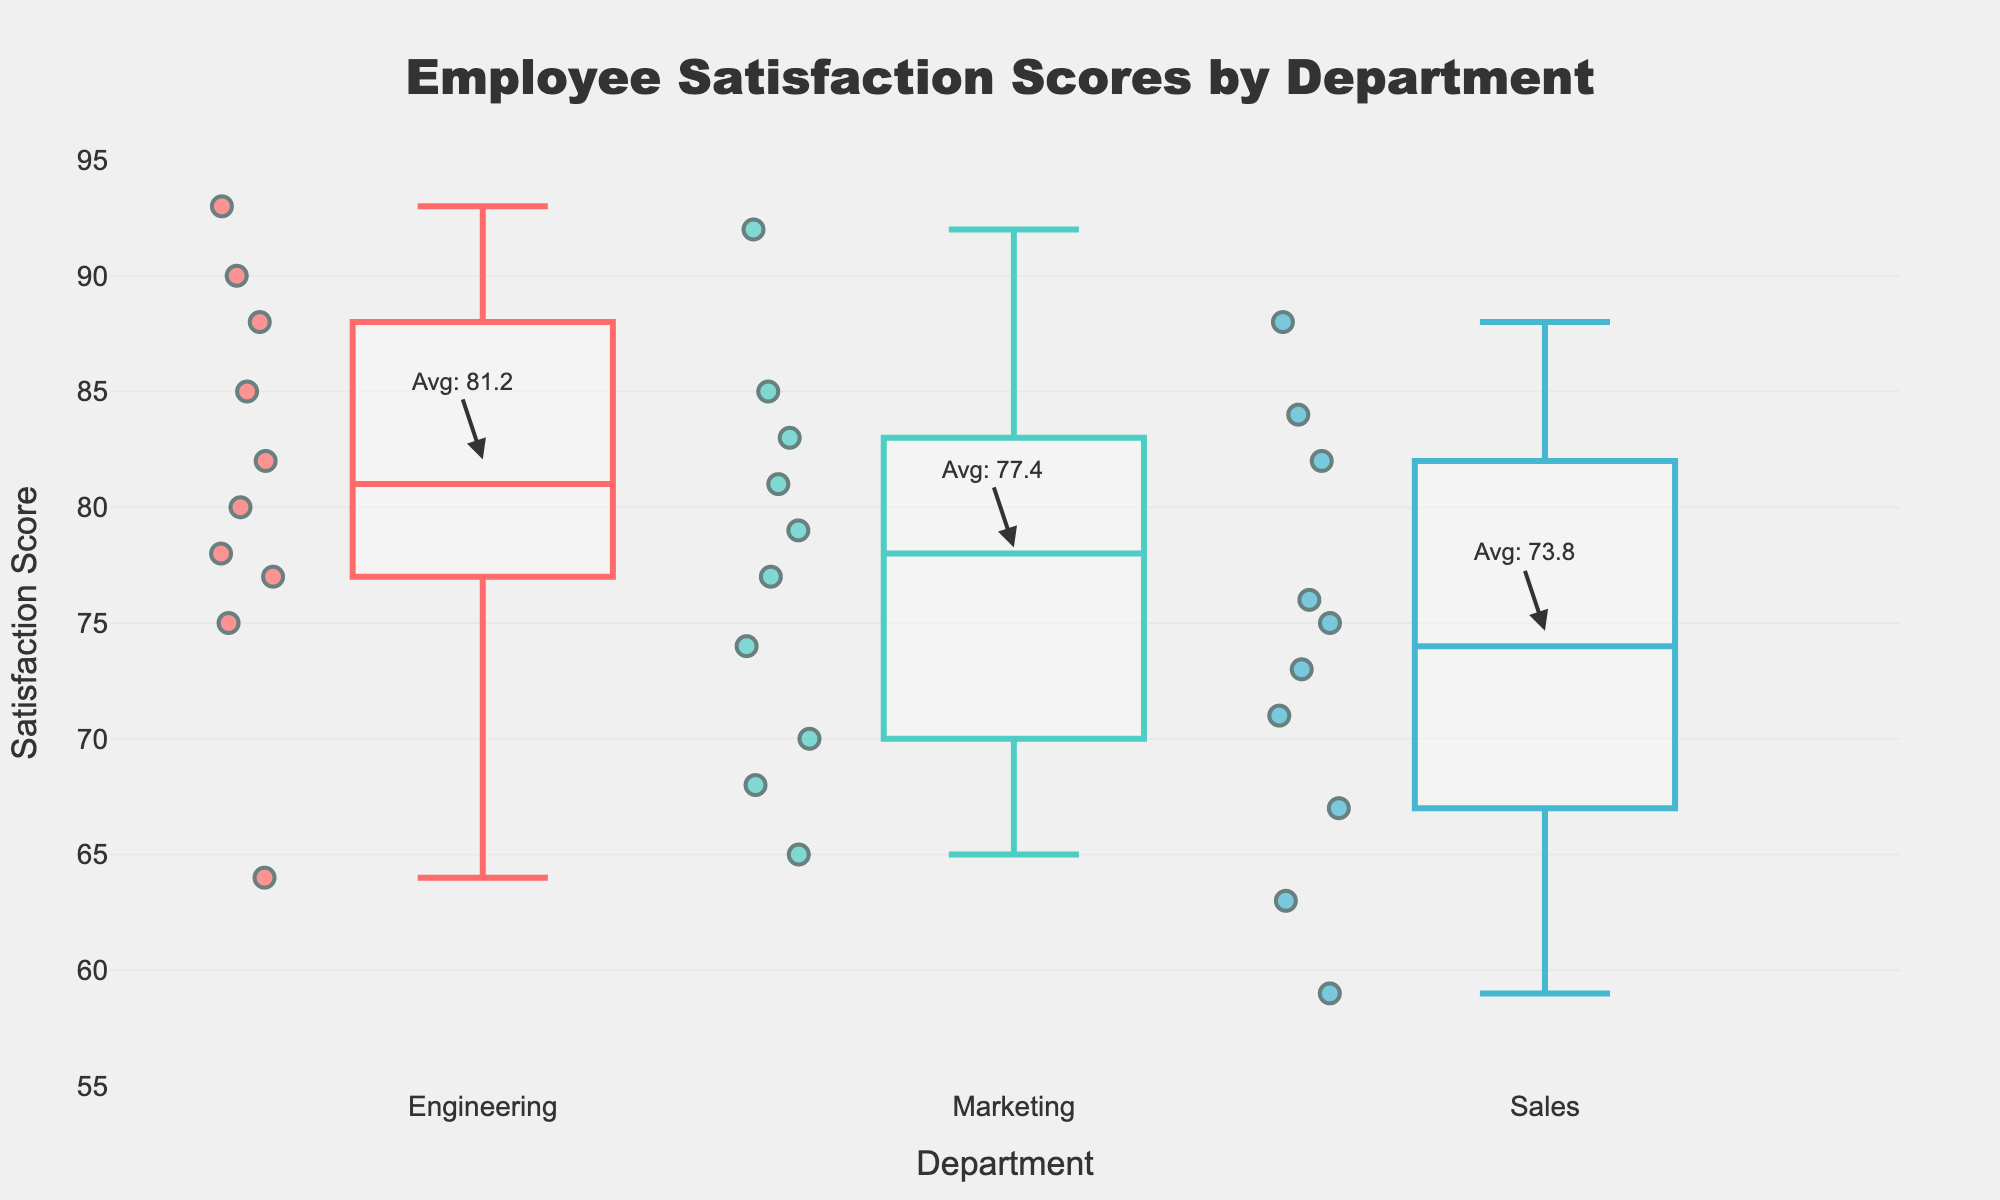1. What are the departments being compared in the figure? The box plot shows three different departments along the x-axis. They are labeled as "Engineering," "Marketing," and "Sales."
Answer: Engineering, Marketing, Sales 2. Which department has the highest average satisfaction score? The average satisfaction scores are annotated on the figure for each department. By comparing these annotations, the highest average score can be identified. Marketing has the highest average score, annotated as Avg: 77.4.
Answer: Marketing 3. How many data points are there in the Engineering department? Each scatter point represents an individual data point. By counting the scatter points within the "Engineering" box plot, we find there are 10 data points.
Answer: 10 4. What is the median satisfaction score of the Sales department? The median is represented by the horizontal line inside the box in the box plot. In the Sales department, this line aligns with the score value of 73.
Answer: 73 5. Which department has the widest range of satisfaction scores? The range can be determined by looking at the highest and lowest points (whiskers) in the box plots for each department. Engineering has scores ranging from 64 to 93, Marketing from 65 to 92, and Sales from 59 to 88. The widest range is in the Sales department.
Answer: Sales 6. What is the lowest satisfaction score in the Marketing department? The lowest point in the box plot for Marketing represents the minimum satisfaction score. This point is at 65.
Answer: 65 7. Does any department have outliers in their satisfaction scores? Outliers in a box plot are usually represented as individual points outside the whiskers. None of the box plots show points that are noticeably distant from the whiskers, indicating no visible outliers.
Answer: No 8. What is the satisfaction score of the employee with the highest score in the figure? The highest satisfaction score is the peak of the tallest whisker in any box plot. This score occurs in the Engineering department at a value of 93.
Answer: 93 9. Compare the average satisfaction scores of Engineering and Marketing departments. Which is higher and by how much? The average scores are given as annotations. Engineering has Avg: 81.2, and Marketing has Avg: 77.4. To find the difference, subtract the average of Marketing from Engineering: 81.2 - 77.4 = 3.8. Engineering's average is higher by 3.8.
Answer: Engineering by 3.8 10. How does the variation in satisfaction scores appear when comparing Engineering to Sales? Variation can be visually compared using the spread of the box plot and whiskers. Engineering has a narrower spread, from 64 to 93, while Sales has a wider spread, from 59 to 88, indicating greater variation in Sales.
Answer: Sales has greater variation 